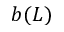<formula> <loc_0><loc_0><loc_500><loc_500>b ( L )</formula> 